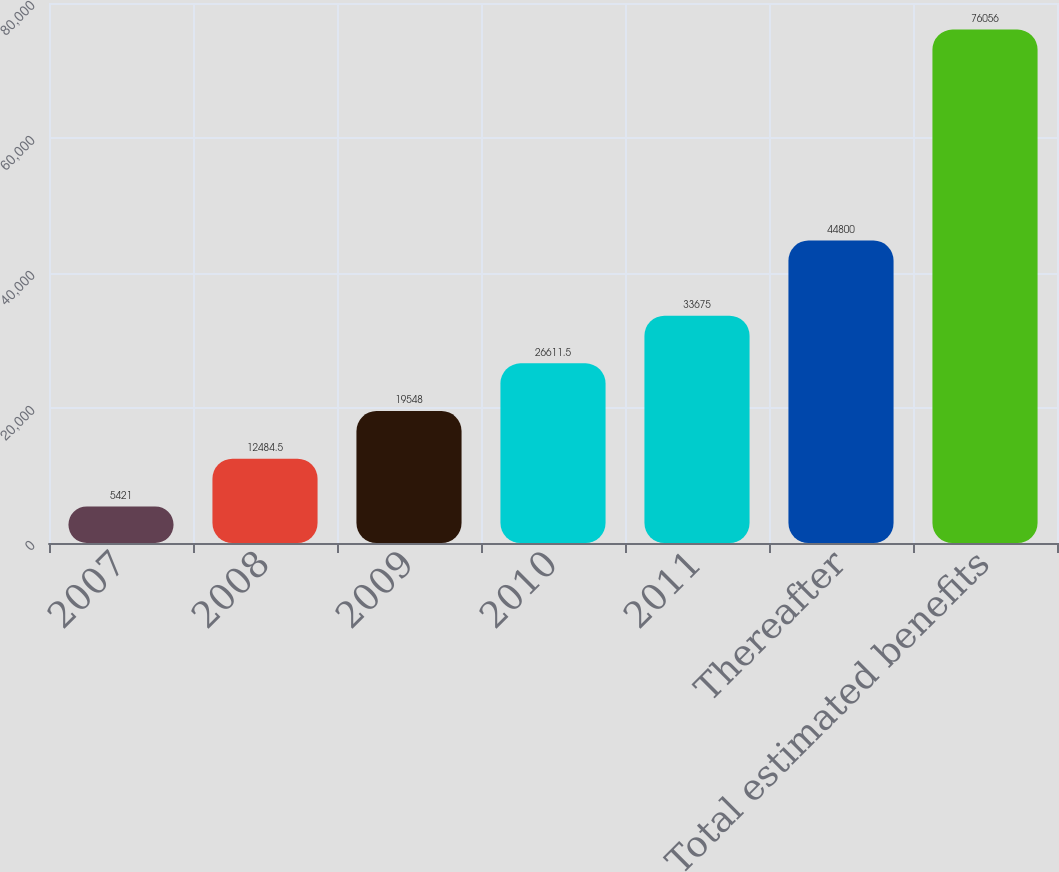<chart> <loc_0><loc_0><loc_500><loc_500><bar_chart><fcel>2007<fcel>2008<fcel>2009<fcel>2010<fcel>2011<fcel>Thereafter<fcel>Total estimated benefits<nl><fcel>5421<fcel>12484.5<fcel>19548<fcel>26611.5<fcel>33675<fcel>44800<fcel>76056<nl></chart> 